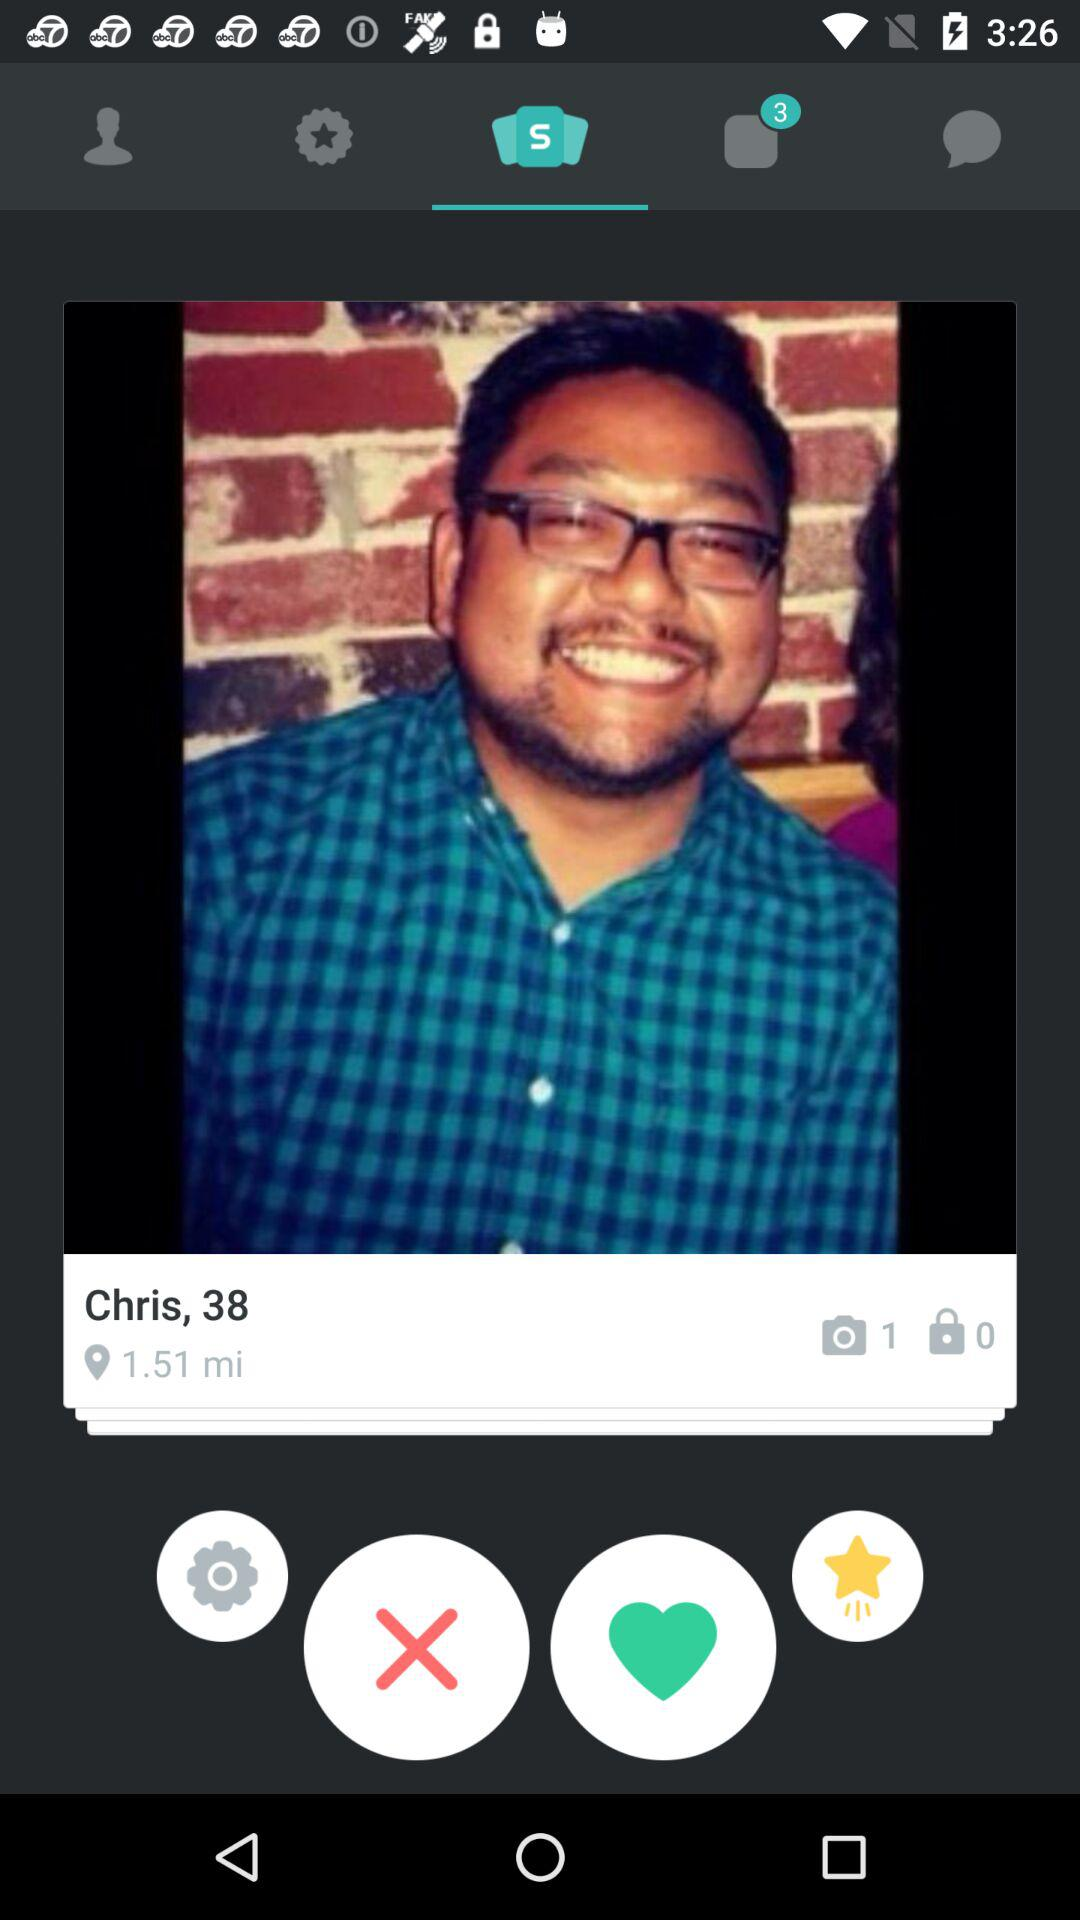How many more photos have been taken than locked?
Answer the question using a single word or phrase. 1 